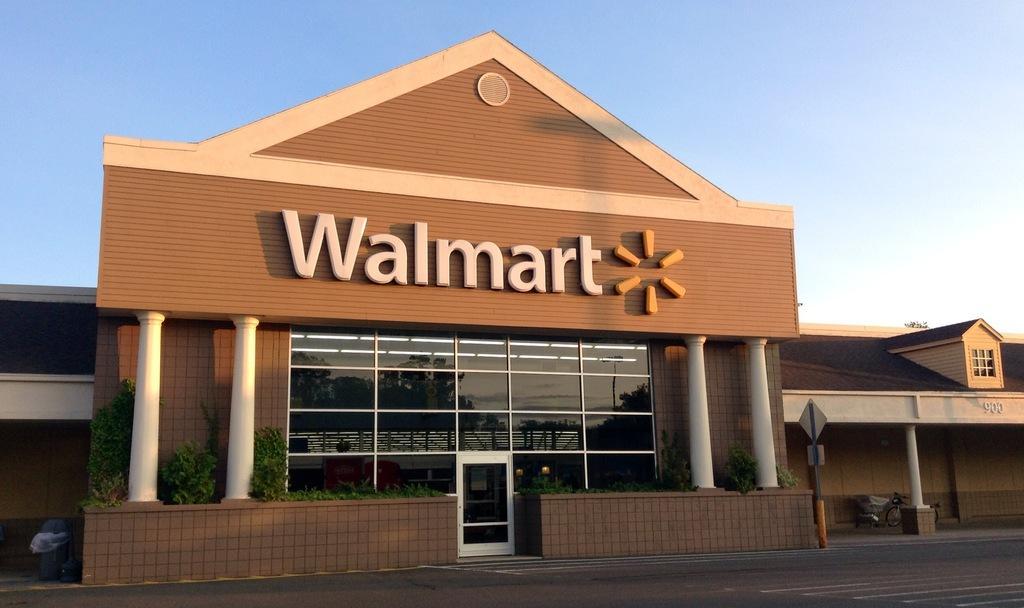Describe this image in one or two sentences. In the foreground of this image, at the bottom, there is the road. In the middle, there is a building, few plants, sign board and few objects. At the top, there is the sky. 